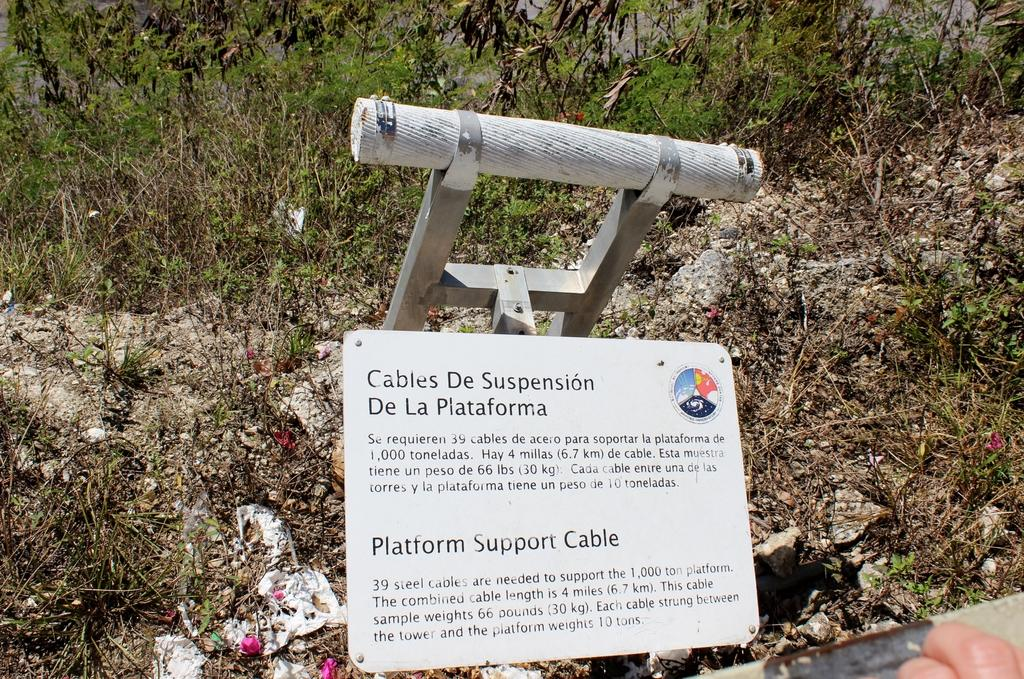What is the main object in the image? There is a board in the image. What is written or depicted on the board? There is text on the board. What can be seen in the background of the image? There are plants on soil in the background of the image. How many forks are visible in the image? There are no forks present in the image. Is there a hand holding the board in the image? There is no hand holding the board in the image. 